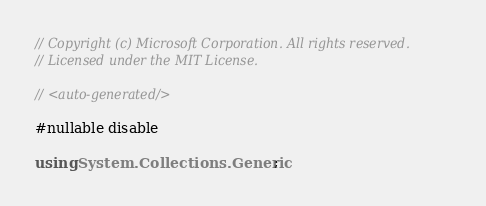<code> <loc_0><loc_0><loc_500><loc_500><_C#_>// Copyright (c) Microsoft Corporation. All rights reserved.
// Licensed under the MIT License.

// <auto-generated/>

#nullable disable

using System.Collections.Generic;</code> 